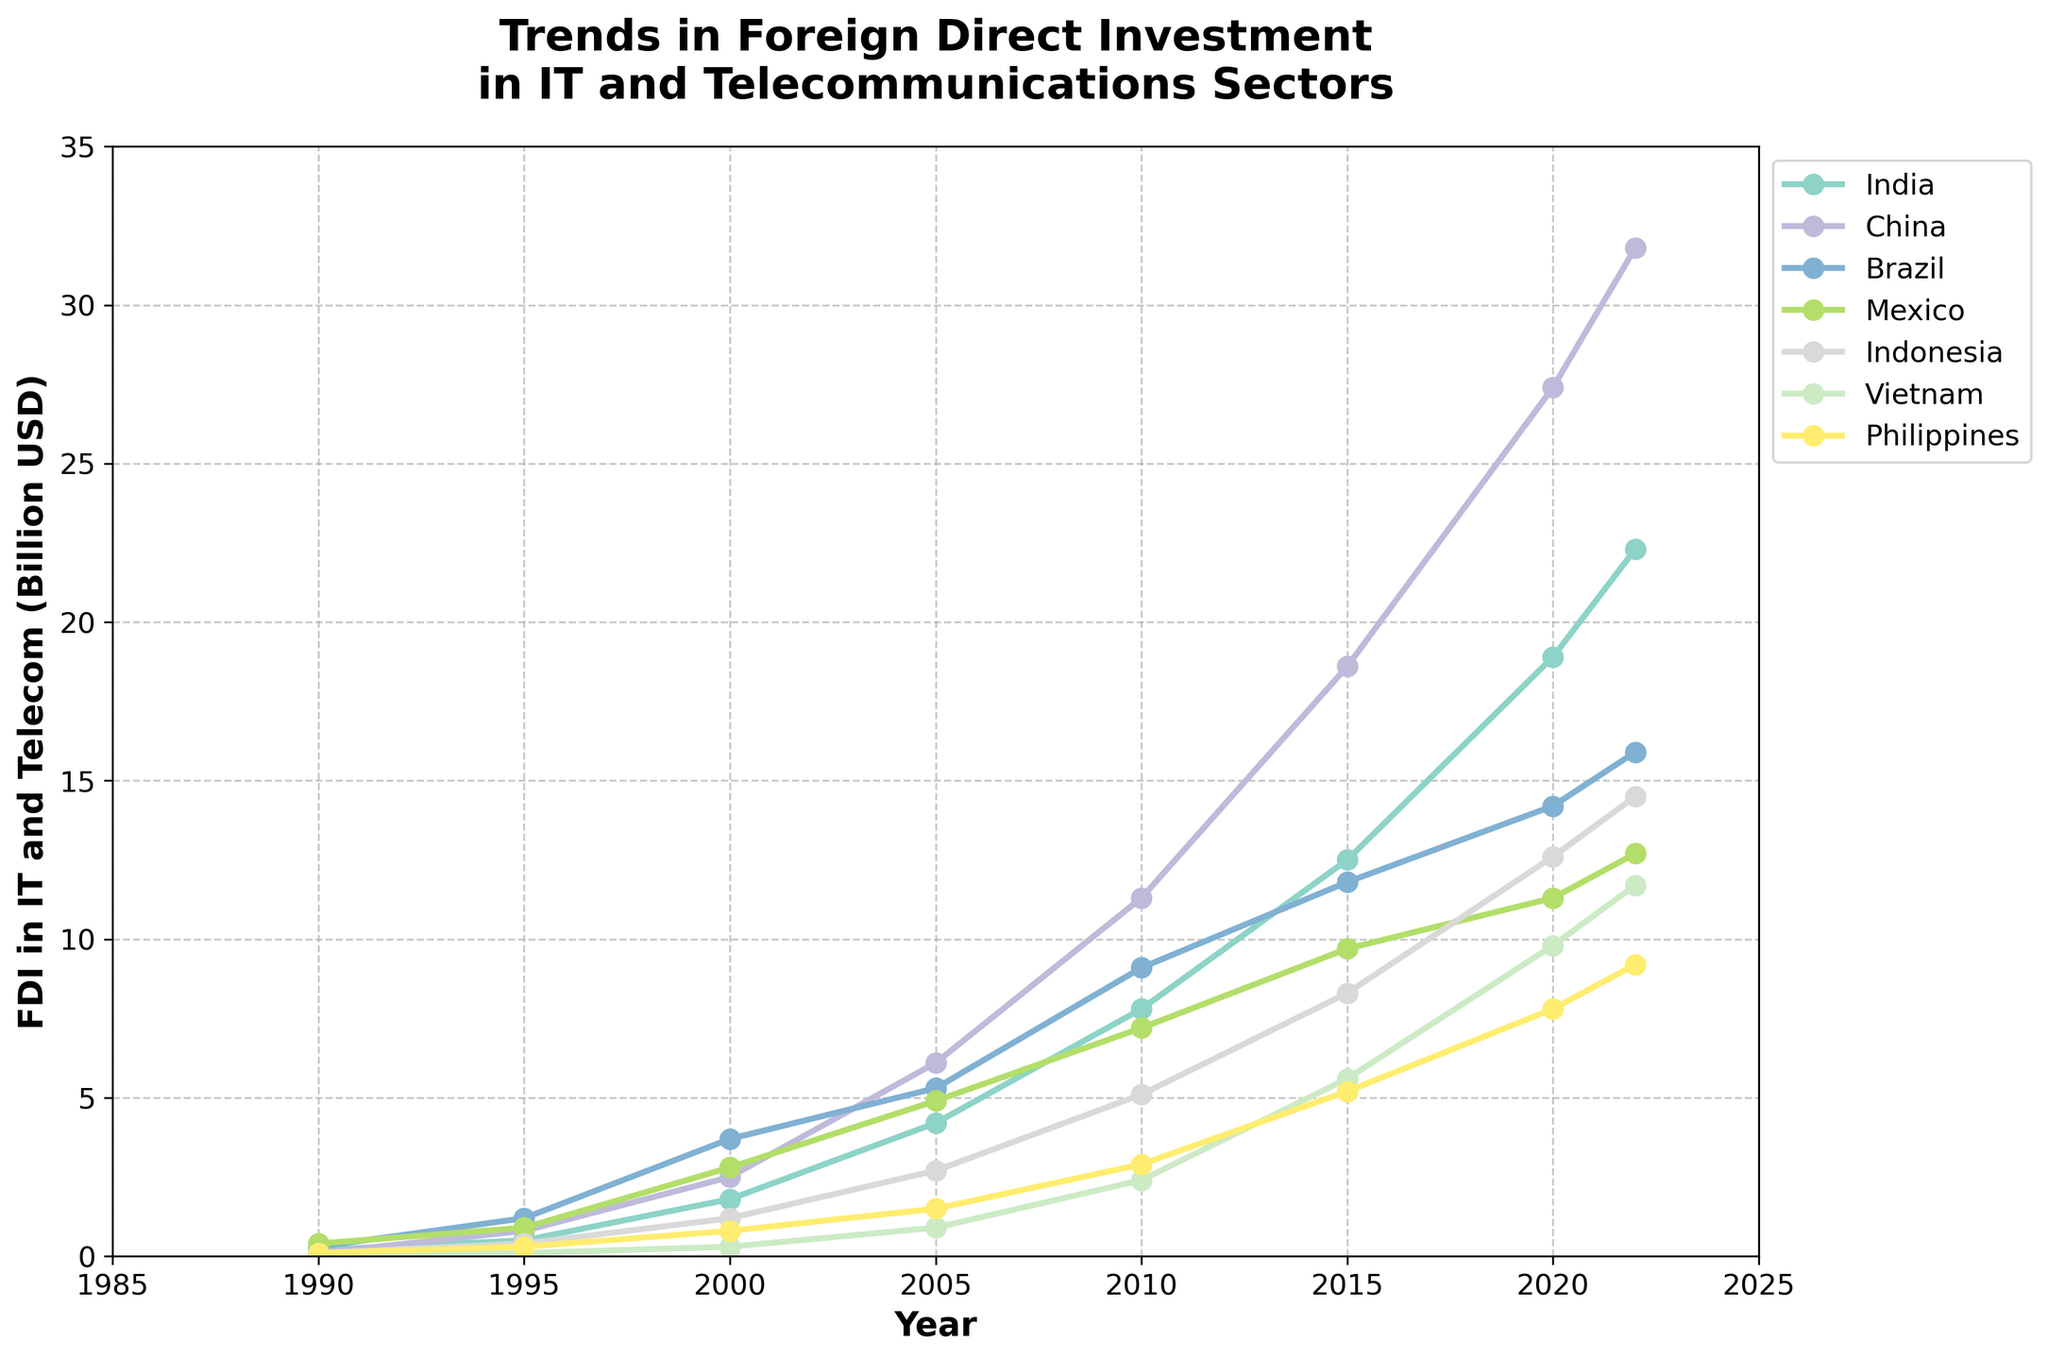What year saw India surpass Brazil in FDI in IT and telecommunications? We observe the FDI values across the years. India surpassed Brazil in 2005. Before 2005, Brazil's FDI was higher than India’s, but in 2005, India had 4.2 billion USD while Brazil had 5.3 billion USD.
Answer: 2005 Which country had the largest FDI in 2022? The figure shows the FDI value for each country in 2022. China had the largest FDI at 31.8 billion USD, significantly higher than any other country.
Answer: China What is the difference in FDI between China and Vietnam in 2020? In 2020, China's FDI is 27.4 billion USD and Vietnam's FDI is 9.8 billion USD. The difference is calculated as 27.4 - 9.8 = 17.6 billion USD.
Answer: 17.6 billion USD Which country had the smallest FDI in 1990, and what was its value? Reviewing the 1990 FDI values, Vietnam had the smallest FDI at 0.0 billion USD.
Answer: Vietnam, 0.0 billion USD Compare the growth in FDI from 1990 to 2022 between India and Mexico. Which country had a higher growth percentage? For India, FDI grew from 0.2 billion USD in 1990 to 22.3 billion USD in 2022, so the growth percentage is ((22.3 - 0.2) / 0.2) * 100 = 11050%. For Mexico, FDI grew from 0.4 billion USD in 1990 to 12.7 billion USD in 2022, so the growth percentage is ((12.7 - 0.4) / 0.4) * 100 = 3075%. India had a higher growth percentage.
Answer: India What is the average FDI in Brazil between 1990 and 2022? The FDI values for Brazil between 1990 and 2022 are 0.3, 1.2, 3.7, 5.3, 9.1, 11.8, 14.2, and 15.9 billion USD. Adding these up: 0.3 + 1.2 + 3.7 + 5.3 + 9.1 + 11.8 + 14.2 + 15.9 = 61.5. There are 8 data points, so the average is 61.5 / 8 = 7.6875 billion USD.
Answer: 7.6875 billion USD Which two countries had the closest FDI values in the year 2010? In 2010, the FDI values are: India (7.8), China (11.3), Brazil (9.1), Mexico (7.2), Indonesia (5.1), Vietnam (2.4), Philippines (2.9). The closest values are for Vietnam and Philippines (2.4 and 2.9 billion USD, respectively).
Answer: Vietnam and Philippines How many years did it take for Indonesia's FDI to increase from 0.1 billion USD to 14.5 billion USD? Indonesia's FDI was 0.1 billion USD in 1990 and 14.5 billion USD in 2022. The number of years between 1990 and 2022 is 32 years.
Answer: 32 years Which country showed the most consistent year-to-year growth in FDI from 1990 to 2022? By observing the trend lines, China shows the most consistent year-to-year increase in FDI, steadily rising from 0.1 billion USD in 1990 to 31.8 billion USD in 2022 without any significant dips.
Answer: China 